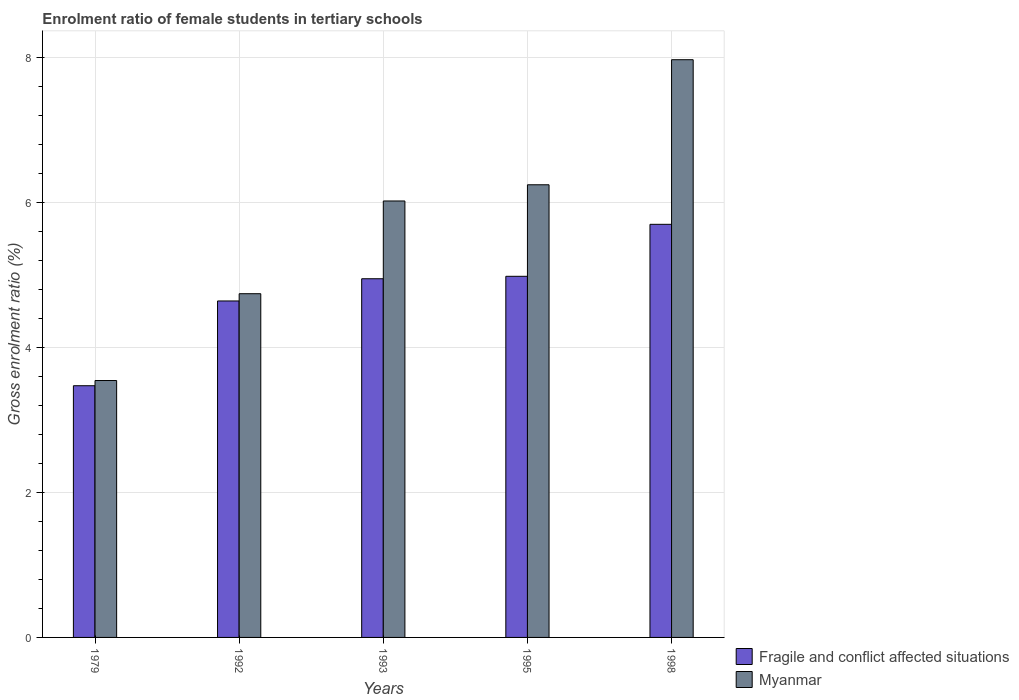Are the number of bars per tick equal to the number of legend labels?
Provide a short and direct response. Yes. Are the number of bars on each tick of the X-axis equal?
Offer a very short reply. Yes. How many bars are there on the 5th tick from the left?
Provide a short and direct response. 2. What is the label of the 2nd group of bars from the left?
Make the answer very short. 1992. In how many cases, is the number of bars for a given year not equal to the number of legend labels?
Your response must be concise. 0. What is the enrolment ratio of female students in tertiary schools in Myanmar in 1979?
Give a very brief answer. 3.54. Across all years, what is the maximum enrolment ratio of female students in tertiary schools in Fragile and conflict affected situations?
Provide a short and direct response. 5.7. Across all years, what is the minimum enrolment ratio of female students in tertiary schools in Fragile and conflict affected situations?
Ensure brevity in your answer.  3.47. In which year was the enrolment ratio of female students in tertiary schools in Fragile and conflict affected situations maximum?
Provide a succinct answer. 1998. In which year was the enrolment ratio of female students in tertiary schools in Myanmar minimum?
Your response must be concise. 1979. What is the total enrolment ratio of female students in tertiary schools in Myanmar in the graph?
Provide a short and direct response. 28.51. What is the difference between the enrolment ratio of female students in tertiary schools in Myanmar in 1995 and that in 1998?
Provide a succinct answer. -1.72. What is the difference between the enrolment ratio of female students in tertiary schools in Fragile and conflict affected situations in 1992 and the enrolment ratio of female students in tertiary schools in Myanmar in 1995?
Offer a terse response. -1.6. What is the average enrolment ratio of female students in tertiary schools in Fragile and conflict affected situations per year?
Offer a very short reply. 4.75. In the year 1998, what is the difference between the enrolment ratio of female students in tertiary schools in Fragile and conflict affected situations and enrolment ratio of female students in tertiary schools in Myanmar?
Keep it short and to the point. -2.27. In how many years, is the enrolment ratio of female students in tertiary schools in Fragile and conflict affected situations greater than 4 %?
Provide a short and direct response. 4. What is the ratio of the enrolment ratio of female students in tertiary schools in Myanmar in 1992 to that in 1995?
Make the answer very short. 0.76. Is the difference between the enrolment ratio of female students in tertiary schools in Fragile and conflict affected situations in 1992 and 1995 greater than the difference between the enrolment ratio of female students in tertiary schools in Myanmar in 1992 and 1995?
Provide a succinct answer. Yes. What is the difference between the highest and the second highest enrolment ratio of female students in tertiary schools in Myanmar?
Your response must be concise. 1.72. What is the difference between the highest and the lowest enrolment ratio of female students in tertiary schools in Fragile and conflict affected situations?
Make the answer very short. 2.23. What does the 2nd bar from the left in 1998 represents?
Ensure brevity in your answer.  Myanmar. What does the 1st bar from the right in 1992 represents?
Offer a very short reply. Myanmar. How many years are there in the graph?
Ensure brevity in your answer.  5. What is the difference between two consecutive major ticks on the Y-axis?
Ensure brevity in your answer.  2. Does the graph contain grids?
Provide a short and direct response. Yes. What is the title of the graph?
Ensure brevity in your answer.  Enrolment ratio of female students in tertiary schools. What is the label or title of the X-axis?
Offer a terse response. Years. What is the Gross enrolment ratio (%) of Fragile and conflict affected situations in 1979?
Keep it short and to the point. 3.47. What is the Gross enrolment ratio (%) of Myanmar in 1979?
Offer a terse response. 3.54. What is the Gross enrolment ratio (%) in Fragile and conflict affected situations in 1992?
Your response must be concise. 4.64. What is the Gross enrolment ratio (%) of Myanmar in 1992?
Offer a terse response. 4.74. What is the Gross enrolment ratio (%) of Fragile and conflict affected situations in 1993?
Ensure brevity in your answer.  4.95. What is the Gross enrolment ratio (%) in Myanmar in 1993?
Your response must be concise. 6.02. What is the Gross enrolment ratio (%) of Fragile and conflict affected situations in 1995?
Provide a short and direct response. 4.98. What is the Gross enrolment ratio (%) of Myanmar in 1995?
Make the answer very short. 6.24. What is the Gross enrolment ratio (%) of Fragile and conflict affected situations in 1998?
Offer a terse response. 5.7. What is the Gross enrolment ratio (%) in Myanmar in 1998?
Your answer should be very brief. 7.97. Across all years, what is the maximum Gross enrolment ratio (%) of Fragile and conflict affected situations?
Keep it short and to the point. 5.7. Across all years, what is the maximum Gross enrolment ratio (%) in Myanmar?
Provide a succinct answer. 7.97. Across all years, what is the minimum Gross enrolment ratio (%) of Fragile and conflict affected situations?
Keep it short and to the point. 3.47. Across all years, what is the minimum Gross enrolment ratio (%) of Myanmar?
Your answer should be very brief. 3.54. What is the total Gross enrolment ratio (%) of Fragile and conflict affected situations in the graph?
Make the answer very short. 23.73. What is the total Gross enrolment ratio (%) of Myanmar in the graph?
Your answer should be very brief. 28.51. What is the difference between the Gross enrolment ratio (%) in Fragile and conflict affected situations in 1979 and that in 1992?
Give a very brief answer. -1.17. What is the difference between the Gross enrolment ratio (%) in Myanmar in 1979 and that in 1992?
Provide a succinct answer. -1.2. What is the difference between the Gross enrolment ratio (%) in Fragile and conflict affected situations in 1979 and that in 1993?
Offer a terse response. -1.48. What is the difference between the Gross enrolment ratio (%) in Myanmar in 1979 and that in 1993?
Provide a short and direct response. -2.48. What is the difference between the Gross enrolment ratio (%) in Fragile and conflict affected situations in 1979 and that in 1995?
Provide a short and direct response. -1.51. What is the difference between the Gross enrolment ratio (%) in Myanmar in 1979 and that in 1995?
Provide a succinct answer. -2.7. What is the difference between the Gross enrolment ratio (%) of Fragile and conflict affected situations in 1979 and that in 1998?
Make the answer very short. -2.23. What is the difference between the Gross enrolment ratio (%) of Myanmar in 1979 and that in 1998?
Provide a short and direct response. -4.42. What is the difference between the Gross enrolment ratio (%) in Fragile and conflict affected situations in 1992 and that in 1993?
Your answer should be very brief. -0.31. What is the difference between the Gross enrolment ratio (%) in Myanmar in 1992 and that in 1993?
Offer a very short reply. -1.28. What is the difference between the Gross enrolment ratio (%) of Fragile and conflict affected situations in 1992 and that in 1995?
Your response must be concise. -0.34. What is the difference between the Gross enrolment ratio (%) of Myanmar in 1992 and that in 1995?
Your answer should be compact. -1.5. What is the difference between the Gross enrolment ratio (%) in Fragile and conflict affected situations in 1992 and that in 1998?
Give a very brief answer. -1.06. What is the difference between the Gross enrolment ratio (%) of Myanmar in 1992 and that in 1998?
Ensure brevity in your answer.  -3.23. What is the difference between the Gross enrolment ratio (%) of Fragile and conflict affected situations in 1993 and that in 1995?
Offer a very short reply. -0.03. What is the difference between the Gross enrolment ratio (%) of Myanmar in 1993 and that in 1995?
Your response must be concise. -0.22. What is the difference between the Gross enrolment ratio (%) in Fragile and conflict affected situations in 1993 and that in 1998?
Make the answer very short. -0.75. What is the difference between the Gross enrolment ratio (%) in Myanmar in 1993 and that in 1998?
Offer a very short reply. -1.95. What is the difference between the Gross enrolment ratio (%) of Fragile and conflict affected situations in 1995 and that in 1998?
Your response must be concise. -0.72. What is the difference between the Gross enrolment ratio (%) in Myanmar in 1995 and that in 1998?
Offer a terse response. -1.72. What is the difference between the Gross enrolment ratio (%) in Fragile and conflict affected situations in 1979 and the Gross enrolment ratio (%) in Myanmar in 1992?
Provide a short and direct response. -1.27. What is the difference between the Gross enrolment ratio (%) of Fragile and conflict affected situations in 1979 and the Gross enrolment ratio (%) of Myanmar in 1993?
Your answer should be very brief. -2.55. What is the difference between the Gross enrolment ratio (%) in Fragile and conflict affected situations in 1979 and the Gross enrolment ratio (%) in Myanmar in 1995?
Your answer should be compact. -2.77. What is the difference between the Gross enrolment ratio (%) of Fragile and conflict affected situations in 1979 and the Gross enrolment ratio (%) of Myanmar in 1998?
Your answer should be compact. -4.5. What is the difference between the Gross enrolment ratio (%) of Fragile and conflict affected situations in 1992 and the Gross enrolment ratio (%) of Myanmar in 1993?
Ensure brevity in your answer.  -1.38. What is the difference between the Gross enrolment ratio (%) of Fragile and conflict affected situations in 1992 and the Gross enrolment ratio (%) of Myanmar in 1995?
Offer a very short reply. -1.6. What is the difference between the Gross enrolment ratio (%) in Fragile and conflict affected situations in 1992 and the Gross enrolment ratio (%) in Myanmar in 1998?
Keep it short and to the point. -3.33. What is the difference between the Gross enrolment ratio (%) of Fragile and conflict affected situations in 1993 and the Gross enrolment ratio (%) of Myanmar in 1995?
Provide a succinct answer. -1.3. What is the difference between the Gross enrolment ratio (%) of Fragile and conflict affected situations in 1993 and the Gross enrolment ratio (%) of Myanmar in 1998?
Provide a succinct answer. -3.02. What is the difference between the Gross enrolment ratio (%) in Fragile and conflict affected situations in 1995 and the Gross enrolment ratio (%) in Myanmar in 1998?
Your response must be concise. -2.99. What is the average Gross enrolment ratio (%) in Fragile and conflict affected situations per year?
Your answer should be very brief. 4.75. What is the average Gross enrolment ratio (%) in Myanmar per year?
Make the answer very short. 5.7. In the year 1979, what is the difference between the Gross enrolment ratio (%) of Fragile and conflict affected situations and Gross enrolment ratio (%) of Myanmar?
Make the answer very short. -0.07. In the year 1992, what is the difference between the Gross enrolment ratio (%) in Fragile and conflict affected situations and Gross enrolment ratio (%) in Myanmar?
Offer a very short reply. -0.1. In the year 1993, what is the difference between the Gross enrolment ratio (%) of Fragile and conflict affected situations and Gross enrolment ratio (%) of Myanmar?
Your answer should be very brief. -1.07. In the year 1995, what is the difference between the Gross enrolment ratio (%) of Fragile and conflict affected situations and Gross enrolment ratio (%) of Myanmar?
Offer a terse response. -1.26. In the year 1998, what is the difference between the Gross enrolment ratio (%) in Fragile and conflict affected situations and Gross enrolment ratio (%) in Myanmar?
Provide a succinct answer. -2.27. What is the ratio of the Gross enrolment ratio (%) of Fragile and conflict affected situations in 1979 to that in 1992?
Your response must be concise. 0.75. What is the ratio of the Gross enrolment ratio (%) of Myanmar in 1979 to that in 1992?
Provide a short and direct response. 0.75. What is the ratio of the Gross enrolment ratio (%) of Fragile and conflict affected situations in 1979 to that in 1993?
Ensure brevity in your answer.  0.7. What is the ratio of the Gross enrolment ratio (%) in Myanmar in 1979 to that in 1993?
Your response must be concise. 0.59. What is the ratio of the Gross enrolment ratio (%) of Fragile and conflict affected situations in 1979 to that in 1995?
Provide a short and direct response. 0.7. What is the ratio of the Gross enrolment ratio (%) of Myanmar in 1979 to that in 1995?
Your answer should be compact. 0.57. What is the ratio of the Gross enrolment ratio (%) in Fragile and conflict affected situations in 1979 to that in 1998?
Provide a short and direct response. 0.61. What is the ratio of the Gross enrolment ratio (%) in Myanmar in 1979 to that in 1998?
Your response must be concise. 0.44. What is the ratio of the Gross enrolment ratio (%) in Fragile and conflict affected situations in 1992 to that in 1993?
Your answer should be very brief. 0.94. What is the ratio of the Gross enrolment ratio (%) in Myanmar in 1992 to that in 1993?
Keep it short and to the point. 0.79. What is the ratio of the Gross enrolment ratio (%) of Fragile and conflict affected situations in 1992 to that in 1995?
Keep it short and to the point. 0.93. What is the ratio of the Gross enrolment ratio (%) of Myanmar in 1992 to that in 1995?
Provide a succinct answer. 0.76. What is the ratio of the Gross enrolment ratio (%) of Fragile and conflict affected situations in 1992 to that in 1998?
Provide a short and direct response. 0.81. What is the ratio of the Gross enrolment ratio (%) in Myanmar in 1992 to that in 1998?
Give a very brief answer. 0.59. What is the ratio of the Gross enrolment ratio (%) in Myanmar in 1993 to that in 1995?
Your response must be concise. 0.96. What is the ratio of the Gross enrolment ratio (%) in Fragile and conflict affected situations in 1993 to that in 1998?
Offer a terse response. 0.87. What is the ratio of the Gross enrolment ratio (%) of Myanmar in 1993 to that in 1998?
Make the answer very short. 0.76. What is the ratio of the Gross enrolment ratio (%) in Fragile and conflict affected situations in 1995 to that in 1998?
Offer a very short reply. 0.87. What is the ratio of the Gross enrolment ratio (%) in Myanmar in 1995 to that in 1998?
Give a very brief answer. 0.78. What is the difference between the highest and the second highest Gross enrolment ratio (%) of Fragile and conflict affected situations?
Keep it short and to the point. 0.72. What is the difference between the highest and the second highest Gross enrolment ratio (%) in Myanmar?
Keep it short and to the point. 1.72. What is the difference between the highest and the lowest Gross enrolment ratio (%) of Fragile and conflict affected situations?
Your answer should be compact. 2.23. What is the difference between the highest and the lowest Gross enrolment ratio (%) in Myanmar?
Provide a succinct answer. 4.42. 